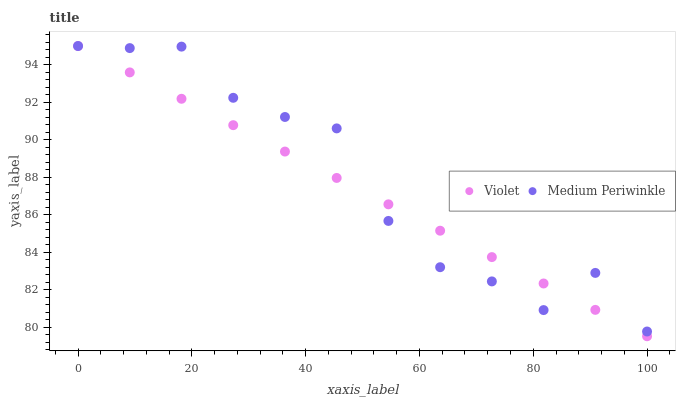Does Violet have the minimum area under the curve?
Answer yes or no. Yes. Does Medium Periwinkle have the maximum area under the curve?
Answer yes or no. Yes. Does Violet have the maximum area under the curve?
Answer yes or no. No. Is Violet the smoothest?
Answer yes or no. Yes. Is Medium Periwinkle the roughest?
Answer yes or no. Yes. Is Violet the roughest?
Answer yes or no. No. Does Violet have the lowest value?
Answer yes or no. Yes. Does Violet have the highest value?
Answer yes or no. Yes. Does Medium Periwinkle intersect Violet?
Answer yes or no. Yes. Is Medium Periwinkle less than Violet?
Answer yes or no. No. Is Medium Periwinkle greater than Violet?
Answer yes or no. No. 